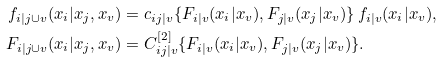<formula> <loc_0><loc_0><loc_500><loc_500>f _ { i | j \cup v } ( x _ { i } | x _ { j } , x _ { v } ) & = c _ { i j | v } \{ F _ { i | v } ( x _ { i } | x _ { v } ) , F _ { j | v } ( x _ { j } | x _ { v } ) \} \, f _ { i | v } ( x _ { i } | x _ { v } ) , \\ F _ { i | j \cup v } ( x _ { i } | x _ { j } , x _ { v } ) & = C _ { i j | v } ^ { [ 2 ] } \{ F _ { i | v } ( x _ { i } | x _ { v } ) , F _ { j | v } ( x _ { j } | x _ { v } ) \} .</formula> 